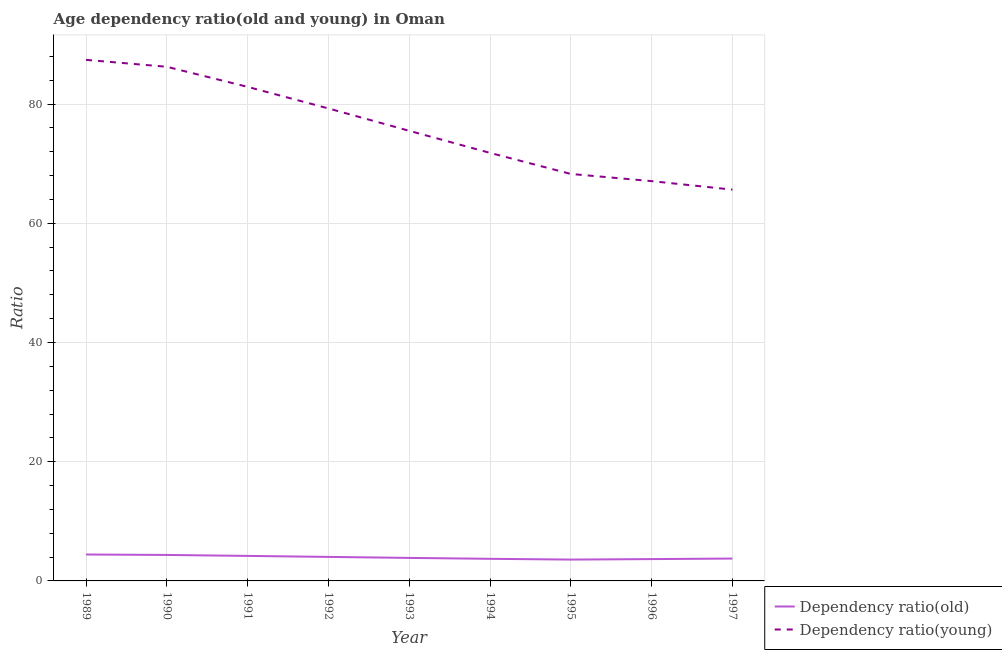Does the line corresponding to age dependency ratio(young) intersect with the line corresponding to age dependency ratio(old)?
Provide a succinct answer. No. Is the number of lines equal to the number of legend labels?
Make the answer very short. Yes. What is the age dependency ratio(young) in 1995?
Provide a succinct answer. 68.27. Across all years, what is the maximum age dependency ratio(old)?
Ensure brevity in your answer.  4.43. Across all years, what is the minimum age dependency ratio(old)?
Give a very brief answer. 3.58. In which year was the age dependency ratio(young) maximum?
Keep it short and to the point. 1989. What is the total age dependency ratio(old) in the graph?
Your answer should be very brief. 35.58. What is the difference between the age dependency ratio(young) in 1992 and that in 1997?
Provide a succinct answer. 13.62. What is the difference between the age dependency ratio(young) in 1997 and the age dependency ratio(old) in 1996?
Keep it short and to the point. 61.98. What is the average age dependency ratio(young) per year?
Your answer should be compact. 76.01. In the year 1994, what is the difference between the age dependency ratio(young) and age dependency ratio(old)?
Your answer should be compact. 68.09. What is the ratio of the age dependency ratio(old) in 1993 to that in 1994?
Keep it short and to the point. 1.04. What is the difference between the highest and the second highest age dependency ratio(young)?
Make the answer very short. 1.16. What is the difference between the highest and the lowest age dependency ratio(young)?
Keep it short and to the point. 21.77. In how many years, is the age dependency ratio(old) greater than the average age dependency ratio(old) taken over all years?
Your answer should be very brief. 4. Is the sum of the age dependency ratio(old) in 1993 and 1994 greater than the maximum age dependency ratio(young) across all years?
Offer a very short reply. No. Does the age dependency ratio(old) monotonically increase over the years?
Provide a succinct answer. No. How many lines are there?
Give a very brief answer. 2. Does the graph contain any zero values?
Give a very brief answer. No. How many legend labels are there?
Provide a succinct answer. 2. How are the legend labels stacked?
Offer a terse response. Vertical. What is the title of the graph?
Keep it short and to the point. Age dependency ratio(old and young) in Oman. Does "Secondary school" appear as one of the legend labels in the graph?
Give a very brief answer. No. What is the label or title of the X-axis?
Make the answer very short. Year. What is the label or title of the Y-axis?
Ensure brevity in your answer.  Ratio. What is the Ratio of Dependency ratio(old) in 1989?
Ensure brevity in your answer.  4.43. What is the Ratio of Dependency ratio(young) in 1989?
Give a very brief answer. 87.41. What is the Ratio in Dependency ratio(old) in 1990?
Keep it short and to the point. 4.36. What is the Ratio in Dependency ratio(young) in 1990?
Your response must be concise. 86.25. What is the Ratio in Dependency ratio(old) in 1991?
Make the answer very short. 4.2. What is the Ratio of Dependency ratio(young) in 1991?
Make the answer very short. 82.88. What is the Ratio in Dependency ratio(old) in 1992?
Offer a terse response. 4.03. What is the Ratio in Dependency ratio(young) in 1992?
Provide a short and direct response. 79.26. What is the Ratio in Dependency ratio(old) in 1993?
Offer a terse response. 3.86. What is the Ratio of Dependency ratio(young) in 1993?
Your answer should be very brief. 75.5. What is the Ratio of Dependency ratio(old) in 1994?
Your response must be concise. 3.71. What is the Ratio of Dependency ratio(young) in 1994?
Your response must be concise. 71.8. What is the Ratio of Dependency ratio(old) in 1995?
Give a very brief answer. 3.58. What is the Ratio in Dependency ratio(young) in 1995?
Make the answer very short. 68.27. What is the Ratio in Dependency ratio(old) in 1996?
Ensure brevity in your answer.  3.66. What is the Ratio of Dependency ratio(young) in 1996?
Make the answer very short. 67.06. What is the Ratio in Dependency ratio(old) in 1997?
Keep it short and to the point. 3.75. What is the Ratio of Dependency ratio(young) in 1997?
Offer a very short reply. 65.64. Across all years, what is the maximum Ratio in Dependency ratio(old)?
Make the answer very short. 4.43. Across all years, what is the maximum Ratio of Dependency ratio(young)?
Your answer should be compact. 87.41. Across all years, what is the minimum Ratio in Dependency ratio(old)?
Offer a very short reply. 3.58. Across all years, what is the minimum Ratio of Dependency ratio(young)?
Make the answer very short. 65.64. What is the total Ratio of Dependency ratio(old) in the graph?
Provide a short and direct response. 35.58. What is the total Ratio of Dependency ratio(young) in the graph?
Ensure brevity in your answer.  684.07. What is the difference between the Ratio of Dependency ratio(old) in 1989 and that in 1990?
Provide a short and direct response. 0.07. What is the difference between the Ratio of Dependency ratio(young) in 1989 and that in 1990?
Ensure brevity in your answer.  1.16. What is the difference between the Ratio of Dependency ratio(old) in 1989 and that in 1991?
Give a very brief answer. 0.23. What is the difference between the Ratio of Dependency ratio(young) in 1989 and that in 1991?
Keep it short and to the point. 4.53. What is the difference between the Ratio of Dependency ratio(old) in 1989 and that in 1992?
Your answer should be very brief. 0.4. What is the difference between the Ratio of Dependency ratio(young) in 1989 and that in 1992?
Provide a short and direct response. 8.15. What is the difference between the Ratio in Dependency ratio(old) in 1989 and that in 1993?
Provide a short and direct response. 0.57. What is the difference between the Ratio in Dependency ratio(young) in 1989 and that in 1993?
Offer a terse response. 11.9. What is the difference between the Ratio in Dependency ratio(old) in 1989 and that in 1994?
Offer a very short reply. 0.72. What is the difference between the Ratio in Dependency ratio(young) in 1989 and that in 1994?
Your answer should be very brief. 15.61. What is the difference between the Ratio of Dependency ratio(old) in 1989 and that in 1995?
Provide a succinct answer. 0.85. What is the difference between the Ratio in Dependency ratio(young) in 1989 and that in 1995?
Your response must be concise. 19.14. What is the difference between the Ratio in Dependency ratio(old) in 1989 and that in 1996?
Make the answer very short. 0.77. What is the difference between the Ratio in Dependency ratio(young) in 1989 and that in 1996?
Your response must be concise. 20.34. What is the difference between the Ratio in Dependency ratio(old) in 1989 and that in 1997?
Offer a terse response. 0.68. What is the difference between the Ratio of Dependency ratio(young) in 1989 and that in 1997?
Your answer should be compact. 21.77. What is the difference between the Ratio in Dependency ratio(old) in 1990 and that in 1991?
Make the answer very short. 0.16. What is the difference between the Ratio of Dependency ratio(young) in 1990 and that in 1991?
Your answer should be compact. 3.37. What is the difference between the Ratio of Dependency ratio(old) in 1990 and that in 1992?
Give a very brief answer. 0.33. What is the difference between the Ratio in Dependency ratio(young) in 1990 and that in 1992?
Offer a terse response. 6.99. What is the difference between the Ratio in Dependency ratio(old) in 1990 and that in 1993?
Your answer should be compact. 0.5. What is the difference between the Ratio in Dependency ratio(young) in 1990 and that in 1993?
Make the answer very short. 10.74. What is the difference between the Ratio in Dependency ratio(old) in 1990 and that in 1994?
Make the answer very short. 0.65. What is the difference between the Ratio of Dependency ratio(young) in 1990 and that in 1994?
Make the answer very short. 14.45. What is the difference between the Ratio of Dependency ratio(old) in 1990 and that in 1995?
Provide a succinct answer. 0.78. What is the difference between the Ratio of Dependency ratio(young) in 1990 and that in 1995?
Ensure brevity in your answer.  17.98. What is the difference between the Ratio in Dependency ratio(old) in 1990 and that in 1996?
Make the answer very short. 0.7. What is the difference between the Ratio of Dependency ratio(young) in 1990 and that in 1996?
Your response must be concise. 19.18. What is the difference between the Ratio of Dependency ratio(old) in 1990 and that in 1997?
Offer a terse response. 0.61. What is the difference between the Ratio of Dependency ratio(young) in 1990 and that in 1997?
Provide a succinct answer. 20.61. What is the difference between the Ratio in Dependency ratio(old) in 1991 and that in 1992?
Your answer should be very brief. 0.17. What is the difference between the Ratio of Dependency ratio(young) in 1991 and that in 1992?
Make the answer very short. 3.62. What is the difference between the Ratio of Dependency ratio(old) in 1991 and that in 1993?
Your answer should be compact. 0.34. What is the difference between the Ratio in Dependency ratio(young) in 1991 and that in 1993?
Offer a very short reply. 7.37. What is the difference between the Ratio of Dependency ratio(old) in 1991 and that in 1994?
Offer a very short reply. 0.49. What is the difference between the Ratio in Dependency ratio(young) in 1991 and that in 1994?
Your response must be concise. 11.08. What is the difference between the Ratio of Dependency ratio(old) in 1991 and that in 1995?
Offer a terse response. 0.62. What is the difference between the Ratio of Dependency ratio(young) in 1991 and that in 1995?
Make the answer very short. 14.61. What is the difference between the Ratio in Dependency ratio(old) in 1991 and that in 1996?
Your answer should be very brief. 0.54. What is the difference between the Ratio of Dependency ratio(young) in 1991 and that in 1996?
Offer a very short reply. 15.81. What is the difference between the Ratio of Dependency ratio(old) in 1991 and that in 1997?
Your response must be concise. 0.44. What is the difference between the Ratio of Dependency ratio(young) in 1991 and that in 1997?
Offer a very short reply. 17.24. What is the difference between the Ratio in Dependency ratio(old) in 1992 and that in 1993?
Offer a terse response. 0.17. What is the difference between the Ratio of Dependency ratio(young) in 1992 and that in 1993?
Offer a terse response. 3.75. What is the difference between the Ratio in Dependency ratio(old) in 1992 and that in 1994?
Give a very brief answer. 0.32. What is the difference between the Ratio in Dependency ratio(young) in 1992 and that in 1994?
Your answer should be very brief. 7.46. What is the difference between the Ratio in Dependency ratio(old) in 1992 and that in 1995?
Your answer should be compact. 0.45. What is the difference between the Ratio in Dependency ratio(young) in 1992 and that in 1995?
Offer a very short reply. 10.99. What is the difference between the Ratio of Dependency ratio(old) in 1992 and that in 1996?
Offer a very short reply. 0.37. What is the difference between the Ratio in Dependency ratio(young) in 1992 and that in 1996?
Make the answer very short. 12.19. What is the difference between the Ratio of Dependency ratio(old) in 1992 and that in 1997?
Offer a very short reply. 0.28. What is the difference between the Ratio in Dependency ratio(young) in 1992 and that in 1997?
Provide a short and direct response. 13.62. What is the difference between the Ratio in Dependency ratio(old) in 1993 and that in 1994?
Make the answer very short. 0.15. What is the difference between the Ratio of Dependency ratio(young) in 1993 and that in 1994?
Provide a succinct answer. 3.7. What is the difference between the Ratio in Dependency ratio(old) in 1993 and that in 1995?
Make the answer very short. 0.28. What is the difference between the Ratio in Dependency ratio(young) in 1993 and that in 1995?
Give a very brief answer. 7.23. What is the difference between the Ratio in Dependency ratio(old) in 1993 and that in 1996?
Your response must be concise. 0.2. What is the difference between the Ratio in Dependency ratio(young) in 1993 and that in 1996?
Keep it short and to the point. 8.44. What is the difference between the Ratio of Dependency ratio(old) in 1993 and that in 1997?
Keep it short and to the point. 0.11. What is the difference between the Ratio in Dependency ratio(young) in 1993 and that in 1997?
Offer a terse response. 9.87. What is the difference between the Ratio of Dependency ratio(old) in 1994 and that in 1995?
Keep it short and to the point. 0.13. What is the difference between the Ratio in Dependency ratio(young) in 1994 and that in 1995?
Make the answer very short. 3.53. What is the difference between the Ratio of Dependency ratio(old) in 1994 and that in 1996?
Make the answer very short. 0.05. What is the difference between the Ratio in Dependency ratio(young) in 1994 and that in 1996?
Your answer should be compact. 4.74. What is the difference between the Ratio in Dependency ratio(old) in 1994 and that in 1997?
Your answer should be very brief. -0.04. What is the difference between the Ratio of Dependency ratio(young) in 1994 and that in 1997?
Make the answer very short. 6.16. What is the difference between the Ratio in Dependency ratio(old) in 1995 and that in 1996?
Make the answer very short. -0.08. What is the difference between the Ratio in Dependency ratio(young) in 1995 and that in 1996?
Ensure brevity in your answer.  1.21. What is the difference between the Ratio in Dependency ratio(old) in 1995 and that in 1997?
Offer a very short reply. -0.17. What is the difference between the Ratio in Dependency ratio(young) in 1995 and that in 1997?
Offer a terse response. 2.63. What is the difference between the Ratio in Dependency ratio(old) in 1996 and that in 1997?
Your answer should be very brief. -0.09. What is the difference between the Ratio of Dependency ratio(young) in 1996 and that in 1997?
Offer a very short reply. 1.43. What is the difference between the Ratio in Dependency ratio(old) in 1989 and the Ratio in Dependency ratio(young) in 1990?
Provide a succinct answer. -81.81. What is the difference between the Ratio in Dependency ratio(old) in 1989 and the Ratio in Dependency ratio(young) in 1991?
Make the answer very short. -78.45. What is the difference between the Ratio of Dependency ratio(old) in 1989 and the Ratio of Dependency ratio(young) in 1992?
Provide a succinct answer. -74.83. What is the difference between the Ratio in Dependency ratio(old) in 1989 and the Ratio in Dependency ratio(young) in 1993?
Offer a terse response. -71.07. What is the difference between the Ratio of Dependency ratio(old) in 1989 and the Ratio of Dependency ratio(young) in 1994?
Your answer should be very brief. -67.37. What is the difference between the Ratio in Dependency ratio(old) in 1989 and the Ratio in Dependency ratio(young) in 1995?
Your answer should be compact. -63.84. What is the difference between the Ratio of Dependency ratio(old) in 1989 and the Ratio of Dependency ratio(young) in 1996?
Your response must be concise. -62.63. What is the difference between the Ratio in Dependency ratio(old) in 1989 and the Ratio in Dependency ratio(young) in 1997?
Ensure brevity in your answer.  -61.21. What is the difference between the Ratio in Dependency ratio(old) in 1990 and the Ratio in Dependency ratio(young) in 1991?
Make the answer very short. -78.52. What is the difference between the Ratio of Dependency ratio(old) in 1990 and the Ratio of Dependency ratio(young) in 1992?
Provide a short and direct response. -74.9. What is the difference between the Ratio of Dependency ratio(old) in 1990 and the Ratio of Dependency ratio(young) in 1993?
Give a very brief answer. -71.15. What is the difference between the Ratio in Dependency ratio(old) in 1990 and the Ratio in Dependency ratio(young) in 1994?
Keep it short and to the point. -67.44. What is the difference between the Ratio of Dependency ratio(old) in 1990 and the Ratio of Dependency ratio(young) in 1995?
Your response must be concise. -63.91. What is the difference between the Ratio in Dependency ratio(old) in 1990 and the Ratio in Dependency ratio(young) in 1996?
Offer a very short reply. -62.71. What is the difference between the Ratio of Dependency ratio(old) in 1990 and the Ratio of Dependency ratio(young) in 1997?
Your answer should be very brief. -61.28. What is the difference between the Ratio of Dependency ratio(old) in 1991 and the Ratio of Dependency ratio(young) in 1992?
Your answer should be very brief. -75.06. What is the difference between the Ratio of Dependency ratio(old) in 1991 and the Ratio of Dependency ratio(young) in 1993?
Your response must be concise. -71.31. What is the difference between the Ratio of Dependency ratio(old) in 1991 and the Ratio of Dependency ratio(young) in 1994?
Provide a short and direct response. -67.6. What is the difference between the Ratio in Dependency ratio(old) in 1991 and the Ratio in Dependency ratio(young) in 1995?
Provide a short and direct response. -64.07. What is the difference between the Ratio of Dependency ratio(old) in 1991 and the Ratio of Dependency ratio(young) in 1996?
Your answer should be compact. -62.87. What is the difference between the Ratio of Dependency ratio(old) in 1991 and the Ratio of Dependency ratio(young) in 1997?
Offer a terse response. -61.44. What is the difference between the Ratio of Dependency ratio(old) in 1992 and the Ratio of Dependency ratio(young) in 1993?
Your answer should be compact. -71.48. What is the difference between the Ratio in Dependency ratio(old) in 1992 and the Ratio in Dependency ratio(young) in 1994?
Provide a short and direct response. -67.77. What is the difference between the Ratio in Dependency ratio(old) in 1992 and the Ratio in Dependency ratio(young) in 1995?
Provide a short and direct response. -64.24. What is the difference between the Ratio of Dependency ratio(old) in 1992 and the Ratio of Dependency ratio(young) in 1996?
Your answer should be very brief. -63.04. What is the difference between the Ratio in Dependency ratio(old) in 1992 and the Ratio in Dependency ratio(young) in 1997?
Ensure brevity in your answer.  -61.61. What is the difference between the Ratio in Dependency ratio(old) in 1993 and the Ratio in Dependency ratio(young) in 1994?
Make the answer very short. -67.94. What is the difference between the Ratio in Dependency ratio(old) in 1993 and the Ratio in Dependency ratio(young) in 1995?
Your answer should be very brief. -64.41. What is the difference between the Ratio of Dependency ratio(old) in 1993 and the Ratio of Dependency ratio(young) in 1996?
Keep it short and to the point. -63.2. What is the difference between the Ratio in Dependency ratio(old) in 1993 and the Ratio in Dependency ratio(young) in 1997?
Keep it short and to the point. -61.78. What is the difference between the Ratio in Dependency ratio(old) in 1994 and the Ratio in Dependency ratio(young) in 1995?
Ensure brevity in your answer.  -64.56. What is the difference between the Ratio in Dependency ratio(old) in 1994 and the Ratio in Dependency ratio(young) in 1996?
Provide a short and direct response. -63.36. What is the difference between the Ratio of Dependency ratio(old) in 1994 and the Ratio of Dependency ratio(young) in 1997?
Offer a very short reply. -61.93. What is the difference between the Ratio of Dependency ratio(old) in 1995 and the Ratio of Dependency ratio(young) in 1996?
Provide a short and direct response. -63.48. What is the difference between the Ratio in Dependency ratio(old) in 1995 and the Ratio in Dependency ratio(young) in 1997?
Provide a short and direct response. -62.06. What is the difference between the Ratio of Dependency ratio(old) in 1996 and the Ratio of Dependency ratio(young) in 1997?
Keep it short and to the point. -61.98. What is the average Ratio of Dependency ratio(old) per year?
Provide a succinct answer. 3.95. What is the average Ratio of Dependency ratio(young) per year?
Your answer should be compact. 76.01. In the year 1989, what is the difference between the Ratio in Dependency ratio(old) and Ratio in Dependency ratio(young)?
Your answer should be very brief. -82.98. In the year 1990, what is the difference between the Ratio of Dependency ratio(old) and Ratio of Dependency ratio(young)?
Offer a very short reply. -81.89. In the year 1991, what is the difference between the Ratio of Dependency ratio(old) and Ratio of Dependency ratio(young)?
Keep it short and to the point. -78.68. In the year 1992, what is the difference between the Ratio in Dependency ratio(old) and Ratio in Dependency ratio(young)?
Give a very brief answer. -75.23. In the year 1993, what is the difference between the Ratio of Dependency ratio(old) and Ratio of Dependency ratio(young)?
Offer a very short reply. -71.64. In the year 1994, what is the difference between the Ratio in Dependency ratio(old) and Ratio in Dependency ratio(young)?
Your answer should be very brief. -68.09. In the year 1995, what is the difference between the Ratio of Dependency ratio(old) and Ratio of Dependency ratio(young)?
Ensure brevity in your answer.  -64.69. In the year 1996, what is the difference between the Ratio in Dependency ratio(old) and Ratio in Dependency ratio(young)?
Offer a terse response. -63.4. In the year 1997, what is the difference between the Ratio of Dependency ratio(old) and Ratio of Dependency ratio(young)?
Your answer should be very brief. -61.89. What is the ratio of the Ratio of Dependency ratio(old) in 1989 to that in 1990?
Give a very brief answer. 1.02. What is the ratio of the Ratio of Dependency ratio(young) in 1989 to that in 1990?
Ensure brevity in your answer.  1.01. What is the ratio of the Ratio of Dependency ratio(old) in 1989 to that in 1991?
Provide a short and direct response. 1.06. What is the ratio of the Ratio of Dependency ratio(young) in 1989 to that in 1991?
Offer a very short reply. 1.05. What is the ratio of the Ratio of Dependency ratio(old) in 1989 to that in 1992?
Offer a terse response. 1.1. What is the ratio of the Ratio in Dependency ratio(young) in 1989 to that in 1992?
Offer a very short reply. 1.1. What is the ratio of the Ratio of Dependency ratio(old) in 1989 to that in 1993?
Make the answer very short. 1.15. What is the ratio of the Ratio in Dependency ratio(young) in 1989 to that in 1993?
Make the answer very short. 1.16. What is the ratio of the Ratio of Dependency ratio(old) in 1989 to that in 1994?
Your response must be concise. 1.2. What is the ratio of the Ratio in Dependency ratio(young) in 1989 to that in 1994?
Your answer should be compact. 1.22. What is the ratio of the Ratio of Dependency ratio(old) in 1989 to that in 1995?
Give a very brief answer. 1.24. What is the ratio of the Ratio in Dependency ratio(young) in 1989 to that in 1995?
Provide a short and direct response. 1.28. What is the ratio of the Ratio in Dependency ratio(old) in 1989 to that in 1996?
Your answer should be very brief. 1.21. What is the ratio of the Ratio in Dependency ratio(young) in 1989 to that in 1996?
Provide a short and direct response. 1.3. What is the ratio of the Ratio of Dependency ratio(old) in 1989 to that in 1997?
Provide a short and direct response. 1.18. What is the ratio of the Ratio of Dependency ratio(young) in 1989 to that in 1997?
Give a very brief answer. 1.33. What is the ratio of the Ratio of Dependency ratio(old) in 1990 to that in 1991?
Ensure brevity in your answer.  1.04. What is the ratio of the Ratio in Dependency ratio(young) in 1990 to that in 1991?
Offer a terse response. 1.04. What is the ratio of the Ratio of Dependency ratio(old) in 1990 to that in 1992?
Your answer should be very brief. 1.08. What is the ratio of the Ratio of Dependency ratio(young) in 1990 to that in 1992?
Your answer should be compact. 1.09. What is the ratio of the Ratio in Dependency ratio(old) in 1990 to that in 1993?
Offer a very short reply. 1.13. What is the ratio of the Ratio of Dependency ratio(young) in 1990 to that in 1993?
Make the answer very short. 1.14. What is the ratio of the Ratio of Dependency ratio(old) in 1990 to that in 1994?
Your answer should be compact. 1.18. What is the ratio of the Ratio in Dependency ratio(young) in 1990 to that in 1994?
Your answer should be very brief. 1.2. What is the ratio of the Ratio of Dependency ratio(old) in 1990 to that in 1995?
Your answer should be compact. 1.22. What is the ratio of the Ratio in Dependency ratio(young) in 1990 to that in 1995?
Your response must be concise. 1.26. What is the ratio of the Ratio in Dependency ratio(old) in 1990 to that in 1996?
Offer a terse response. 1.19. What is the ratio of the Ratio in Dependency ratio(young) in 1990 to that in 1996?
Your response must be concise. 1.29. What is the ratio of the Ratio of Dependency ratio(old) in 1990 to that in 1997?
Your answer should be compact. 1.16. What is the ratio of the Ratio of Dependency ratio(young) in 1990 to that in 1997?
Your answer should be compact. 1.31. What is the ratio of the Ratio of Dependency ratio(old) in 1991 to that in 1992?
Offer a terse response. 1.04. What is the ratio of the Ratio in Dependency ratio(young) in 1991 to that in 1992?
Give a very brief answer. 1.05. What is the ratio of the Ratio of Dependency ratio(old) in 1991 to that in 1993?
Offer a terse response. 1.09. What is the ratio of the Ratio in Dependency ratio(young) in 1991 to that in 1993?
Your answer should be compact. 1.1. What is the ratio of the Ratio in Dependency ratio(old) in 1991 to that in 1994?
Provide a succinct answer. 1.13. What is the ratio of the Ratio of Dependency ratio(young) in 1991 to that in 1994?
Provide a succinct answer. 1.15. What is the ratio of the Ratio in Dependency ratio(old) in 1991 to that in 1995?
Offer a very short reply. 1.17. What is the ratio of the Ratio of Dependency ratio(young) in 1991 to that in 1995?
Offer a very short reply. 1.21. What is the ratio of the Ratio of Dependency ratio(old) in 1991 to that in 1996?
Offer a very short reply. 1.15. What is the ratio of the Ratio in Dependency ratio(young) in 1991 to that in 1996?
Provide a succinct answer. 1.24. What is the ratio of the Ratio of Dependency ratio(old) in 1991 to that in 1997?
Provide a succinct answer. 1.12. What is the ratio of the Ratio of Dependency ratio(young) in 1991 to that in 1997?
Keep it short and to the point. 1.26. What is the ratio of the Ratio in Dependency ratio(old) in 1992 to that in 1993?
Your answer should be very brief. 1.04. What is the ratio of the Ratio in Dependency ratio(young) in 1992 to that in 1993?
Your response must be concise. 1.05. What is the ratio of the Ratio in Dependency ratio(old) in 1992 to that in 1994?
Provide a succinct answer. 1.09. What is the ratio of the Ratio of Dependency ratio(young) in 1992 to that in 1994?
Your answer should be compact. 1.1. What is the ratio of the Ratio of Dependency ratio(old) in 1992 to that in 1995?
Your answer should be very brief. 1.13. What is the ratio of the Ratio in Dependency ratio(young) in 1992 to that in 1995?
Provide a succinct answer. 1.16. What is the ratio of the Ratio in Dependency ratio(old) in 1992 to that in 1996?
Ensure brevity in your answer.  1.1. What is the ratio of the Ratio in Dependency ratio(young) in 1992 to that in 1996?
Your answer should be compact. 1.18. What is the ratio of the Ratio in Dependency ratio(old) in 1992 to that in 1997?
Provide a succinct answer. 1.07. What is the ratio of the Ratio of Dependency ratio(young) in 1992 to that in 1997?
Ensure brevity in your answer.  1.21. What is the ratio of the Ratio in Dependency ratio(old) in 1993 to that in 1994?
Your response must be concise. 1.04. What is the ratio of the Ratio of Dependency ratio(young) in 1993 to that in 1994?
Ensure brevity in your answer.  1.05. What is the ratio of the Ratio in Dependency ratio(old) in 1993 to that in 1995?
Give a very brief answer. 1.08. What is the ratio of the Ratio of Dependency ratio(young) in 1993 to that in 1995?
Give a very brief answer. 1.11. What is the ratio of the Ratio of Dependency ratio(old) in 1993 to that in 1996?
Provide a short and direct response. 1.05. What is the ratio of the Ratio of Dependency ratio(young) in 1993 to that in 1996?
Give a very brief answer. 1.13. What is the ratio of the Ratio in Dependency ratio(old) in 1993 to that in 1997?
Your answer should be very brief. 1.03. What is the ratio of the Ratio in Dependency ratio(young) in 1993 to that in 1997?
Your response must be concise. 1.15. What is the ratio of the Ratio of Dependency ratio(old) in 1994 to that in 1995?
Your response must be concise. 1.04. What is the ratio of the Ratio in Dependency ratio(young) in 1994 to that in 1995?
Keep it short and to the point. 1.05. What is the ratio of the Ratio of Dependency ratio(old) in 1994 to that in 1996?
Keep it short and to the point. 1.01. What is the ratio of the Ratio of Dependency ratio(young) in 1994 to that in 1996?
Offer a terse response. 1.07. What is the ratio of the Ratio in Dependency ratio(old) in 1994 to that in 1997?
Provide a short and direct response. 0.99. What is the ratio of the Ratio of Dependency ratio(young) in 1994 to that in 1997?
Provide a short and direct response. 1.09. What is the ratio of the Ratio of Dependency ratio(old) in 1995 to that in 1996?
Offer a terse response. 0.98. What is the ratio of the Ratio in Dependency ratio(old) in 1995 to that in 1997?
Your answer should be very brief. 0.95. What is the ratio of the Ratio in Dependency ratio(young) in 1995 to that in 1997?
Ensure brevity in your answer.  1.04. What is the ratio of the Ratio of Dependency ratio(old) in 1996 to that in 1997?
Your response must be concise. 0.98. What is the ratio of the Ratio of Dependency ratio(young) in 1996 to that in 1997?
Give a very brief answer. 1.02. What is the difference between the highest and the second highest Ratio of Dependency ratio(old)?
Keep it short and to the point. 0.07. What is the difference between the highest and the second highest Ratio of Dependency ratio(young)?
Give a very brief answer. 1.16. What is the difference between the highest and the lowest Ratio of Dependency ratio(old)?
Your answer should be very brief. 0.85. What is the difference between the highest and the lowest Ratio of Dependency ratio(young)?
Your answer should be very brief. 21.77. 